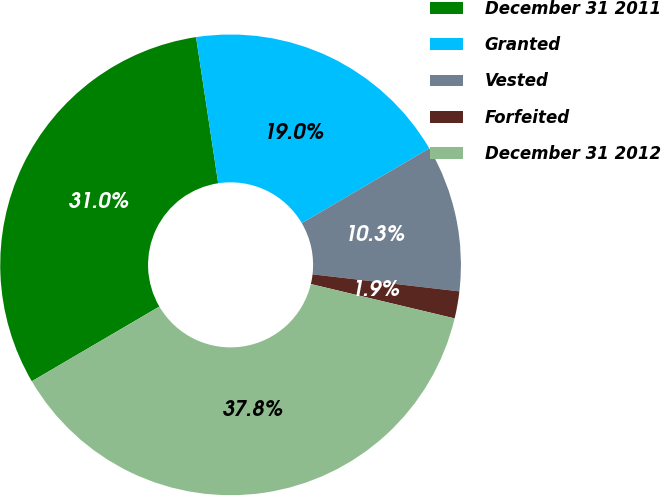Convert chart. <chart><loc_0><loc_0><loc_500><loc_500><pie_chart><fcel>December 31 2011<fcel>Granted<fcel>Vested<fcel>Forfeited<fcel>December 31 2012<nl><fcel>31.04%<fcel>18.96%<fcel>10.27%<fcel>1.9%<fcel>37.83%<nl></chart> 